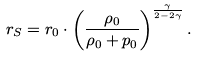<formula> <loc_0><loc_0><loc_500><loc_500>r _ { S } = r _ { 0 } \cdot \left ( \frac { \rho _ { 0 } } { \rho _ { 0 } + p _ { 0 } } \right ) ^ { \frac { \gamma } { 2 - 2 \gamma } } .</formula> 